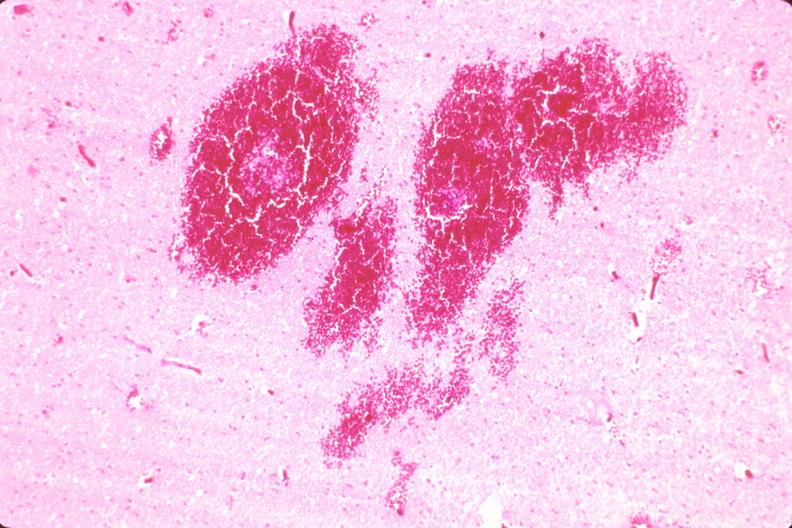s nervous present?
Answer the question using a single word or phrase. Yes 